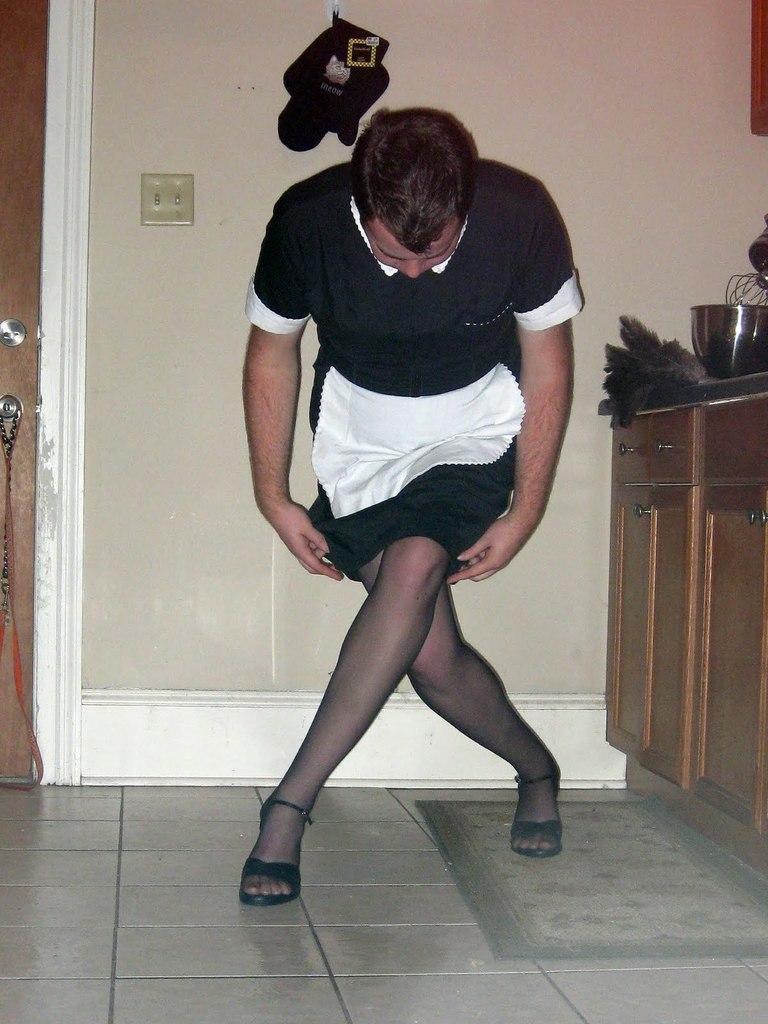In one or two sentences, can you explain what this image depicts? In the picture I can see a person wearing black dress and there are few objects in the right corner and there is a door and there is an object attached to the wall in the background. 